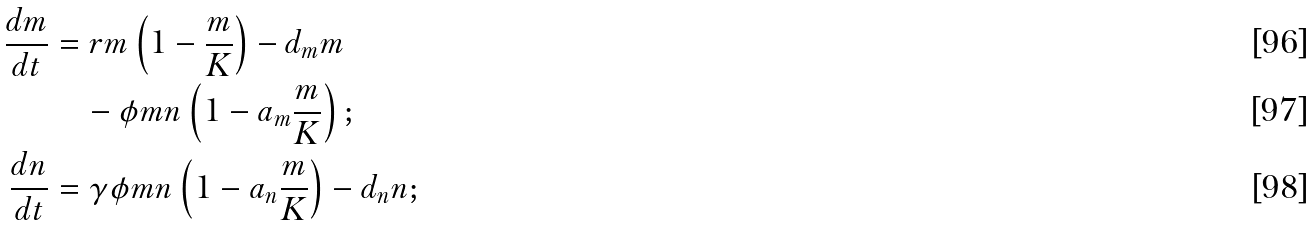Convert formula to latex. <formula><loc_0><loc_0><loc_500><loc_500>\frac { d m } { d t } & = r m \left ( 1 - \frac { m } { K } \right ) - d _ { m } m \\ & \quad - \phi m n \left ( 1 - a _ { m } \frac { m } { K } \right ) ; \\ \frac { d n } { d t } & = \gamma \phi m n \left ( 1 - a _ { n } \frac { m } { K } \right ) - d _ { n } n ;</formula> 